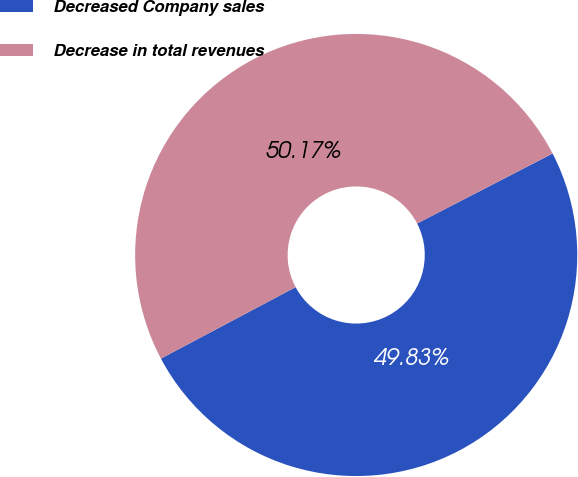Convert chart to OTSL. <chart><loc_0><loc_0><loc_500><loc_500><pie_chart><fcel>Decreased Company sales<fcel>Decrease in total revenues<nl><fcel>49.83%<fcel>50.17%<nl></chart> 